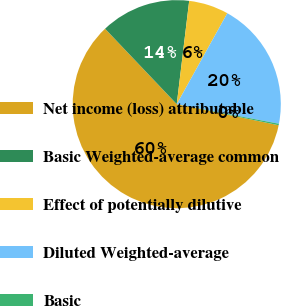<chart> <loc_0><loc_0><loc_500><loc_500><pie_chart><fcel>Net income (loss) attributable<fcel>Basic Weighted-average common<fcel>Effect of potentially dilutive<fcel>Diluted Weighted-average<fcel>Basic<nl><fcel>59.66%<fcel>14.0%<fcel>6.17%<fcel>19.94%<fcel>0.23%<nl></chart> 